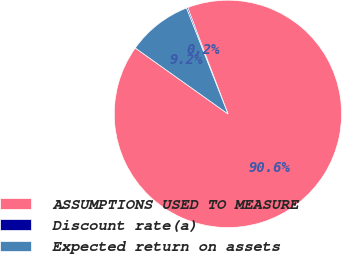Convert chart to OTSL. <chart><loc_0><loc_0><loc_500><loc_500><pie_chart><fcel>ASSUMPTIONS USED TO MEASURE<fcel>Discount rate(a)<fcel>Expected return on assets<nl><fcel>90.6%<fcel>0.18%<fcel>9.22%<nl></chart> 